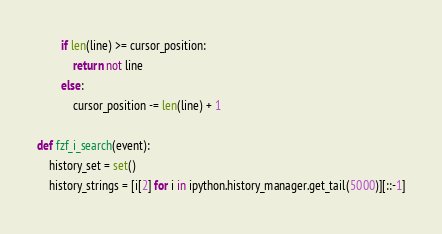<code> <loc_0><loc_0><loc_500><loc_500><_Python_>        if len(line) >= cursor_position:
            return not line
        else:
            cursor_position -= len(line) + 1

def fzf_i_search(event):
    history_set = set()
    history_strings = [i[2] for i in ipython.history_manager.get_tail(5000)][::-1]
</code> 